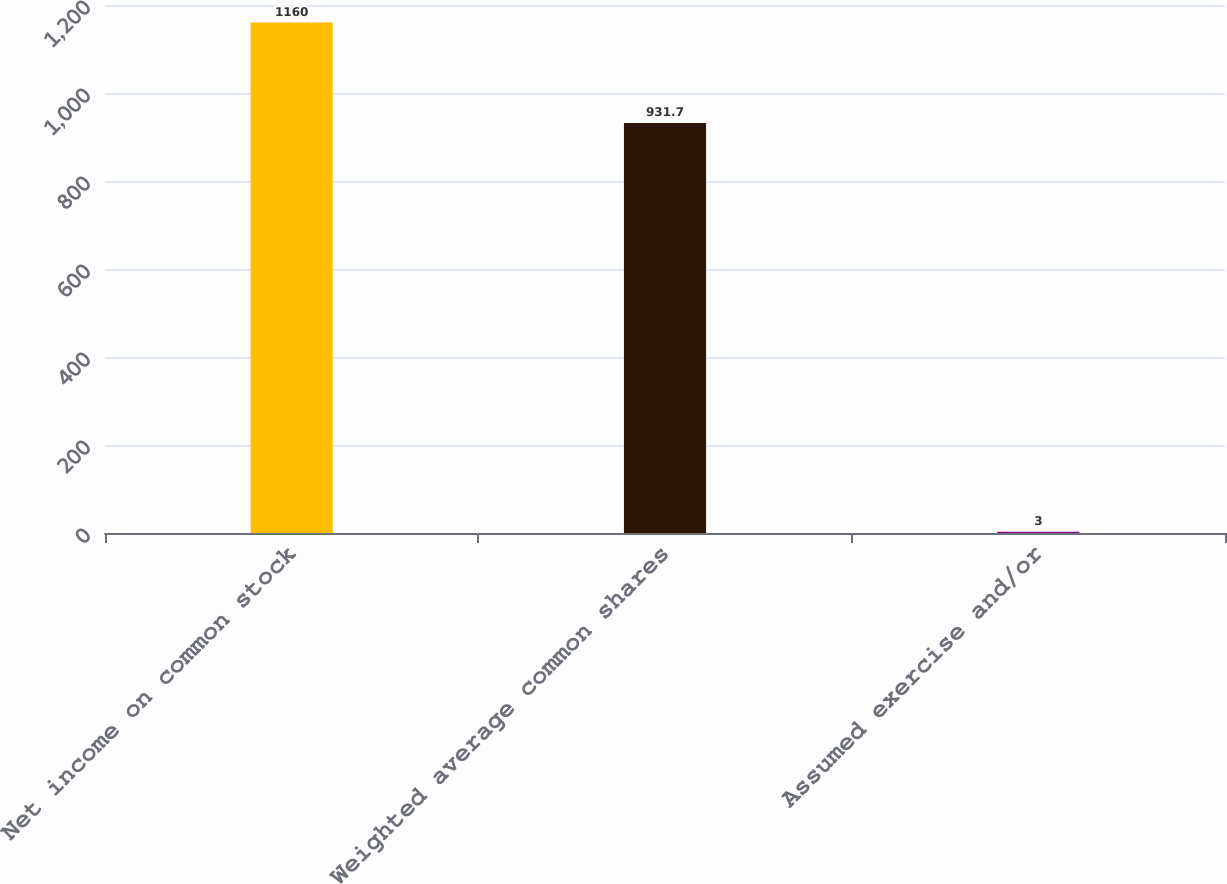<chart> <loc_0><loc_0><loc_500><loc_500><bar_chart><fcel>Net income on common stock<fcel>Weighted average common shares<fcel>Assumed exercise and/or<nl><fcel>1160<fcel>931.7<fcel>3<nl></chart> 